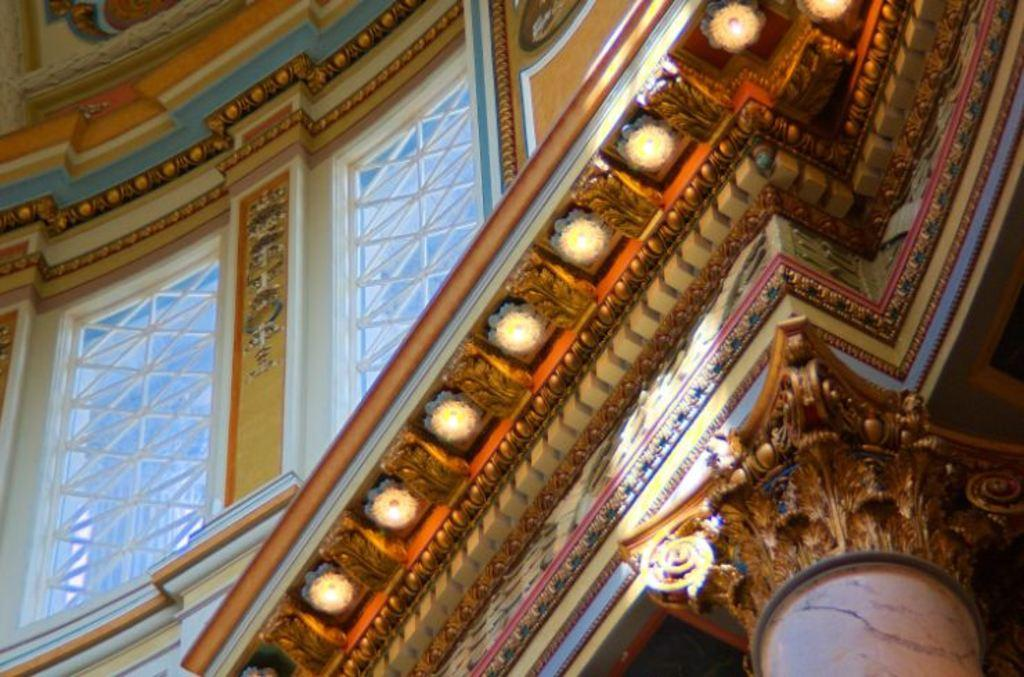Where was the image taken? The image was taken in a Cathedral. What can be seen on the wall in the image? There is a wall with windows in the image. What type of artwork is present in the image? There are sculptures and carvings in the image. What is used for illumination in the image? There are lamps in the image. What type of interest can be seen growing on the sculptures in the image? There is no mention of any plants or interest growing on the sculptures in the image. 